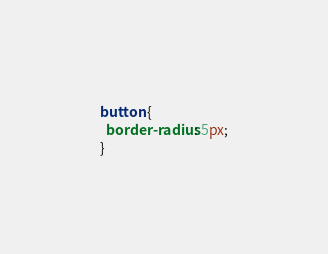<code> <loc_0><loc_0><loc_500><loc_500><_CSS_>button {
  border-radius: 5px;
}
</code> 